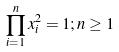<formula> <loc_0><loc_0><loc_500><loc_500>\prod _ { i = 1 } ^ { n } x _ { i } ^ { 2 } = 1 ; n \geq 1</formula> 